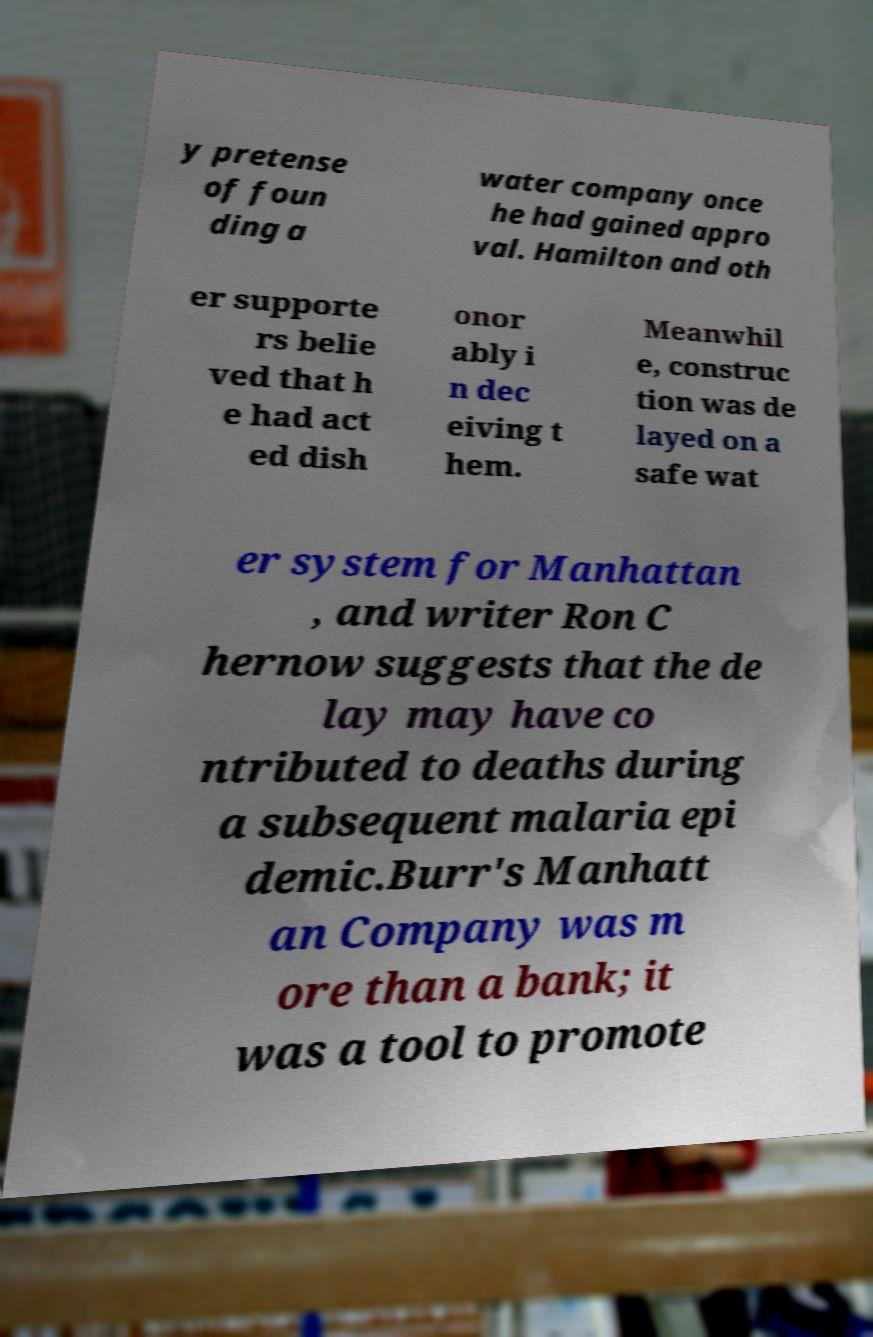Can you accurately transcribe the text from the provided image for me? y pretense of foun ding a water company once he had gained appro val. Hamilton and oth er supporte rs belie ved that h e had act ed dish onor ably i n dec eiving t hem. Meanwhil e, construc tion was de layed on a safe wat er system for Manhattan , and writer Ron C hernow suggests that the de lay may have co ntributed to deaths during a subsequent malaria epi demic.Burr's Manhatt an Company was m ore than a bank; it was a tool to promote 